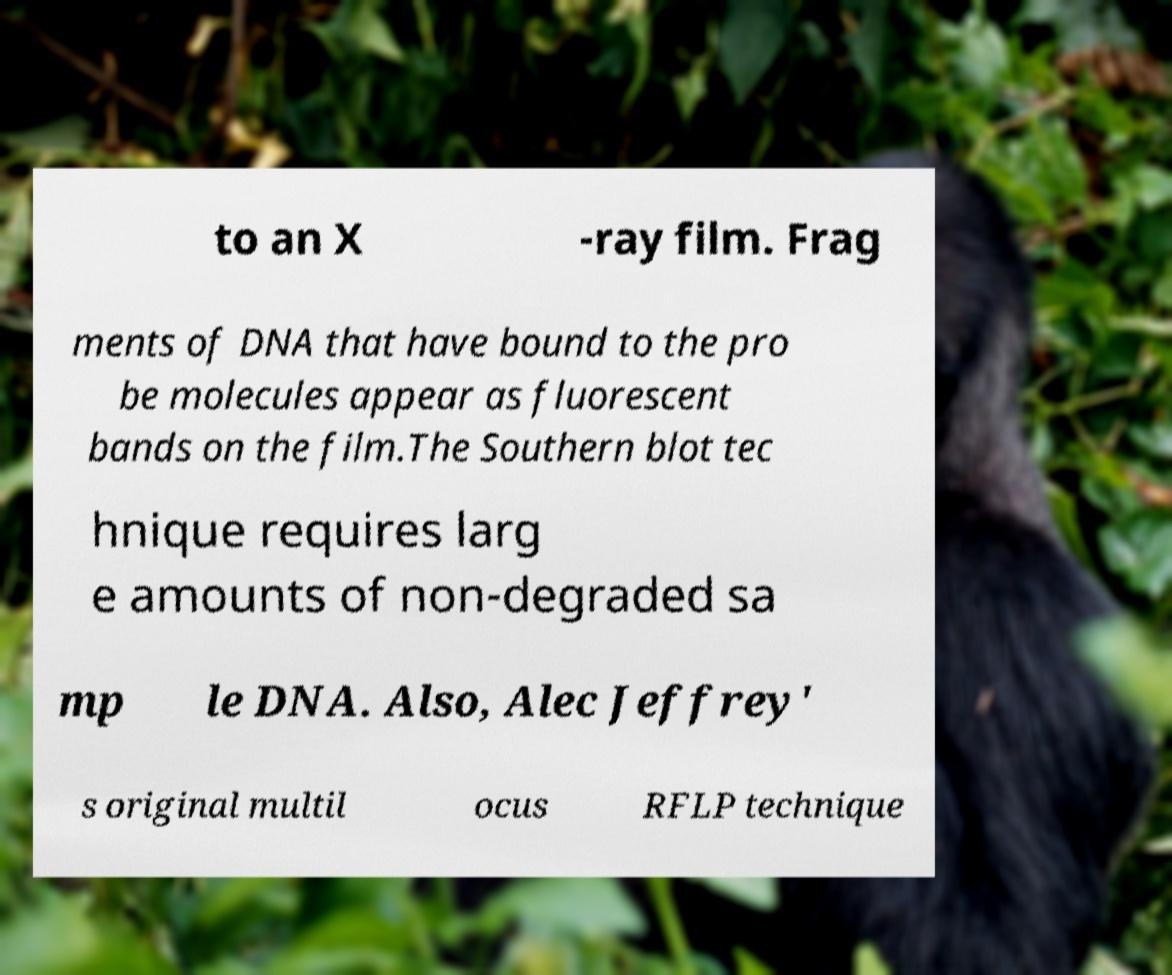Please identify and transcribe the text found in this image. to an X -ray film. Frag ments of DNA that have bound to the pro be molecules appear as fluorescent bands on the film.The Southern blot tec hnique requires larg e amounts of non-degraded sa mp le DNA. Also, Alec Jeffrey' s original multil ocus RFLP technique 